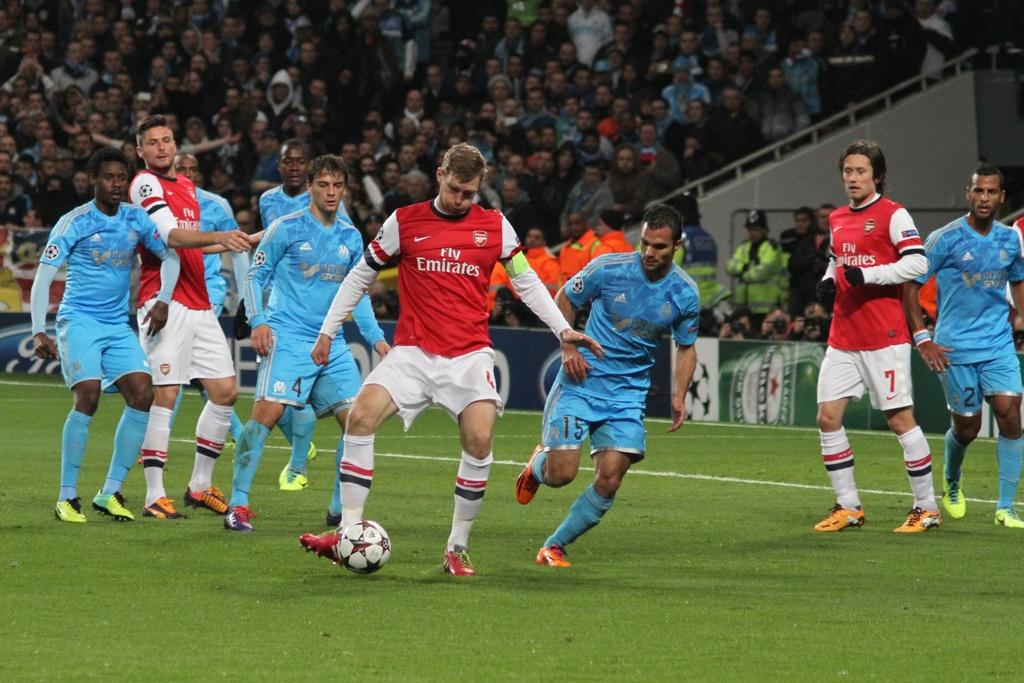<image>
Write a terse but informative summary of the picture. A soccer player in a Fly Emirates jersey kicks a soccer ball. 